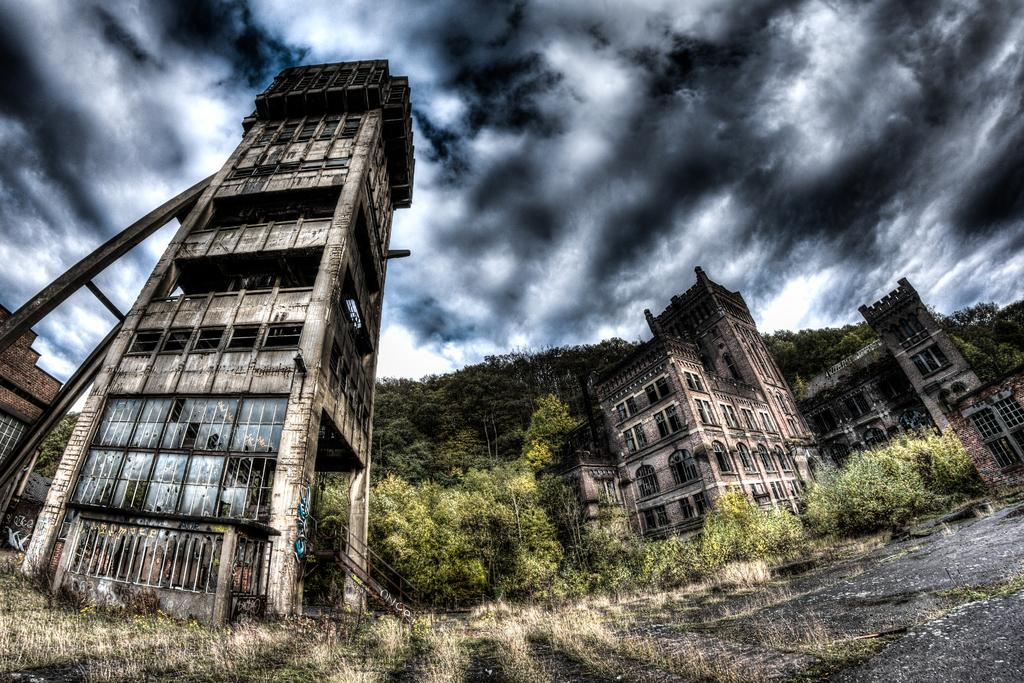What type of structures can be seen in the image? There are buildings in the image. What other natural elements are present in the image? There are trees in the image. What is visible in the background of the image? The sky is visible in the image. Can you describe the sky in the image? Clouds are present in the sky. What type of power is being generated by the trees in the image? There is no indication in the image that the trees are generating any power. 